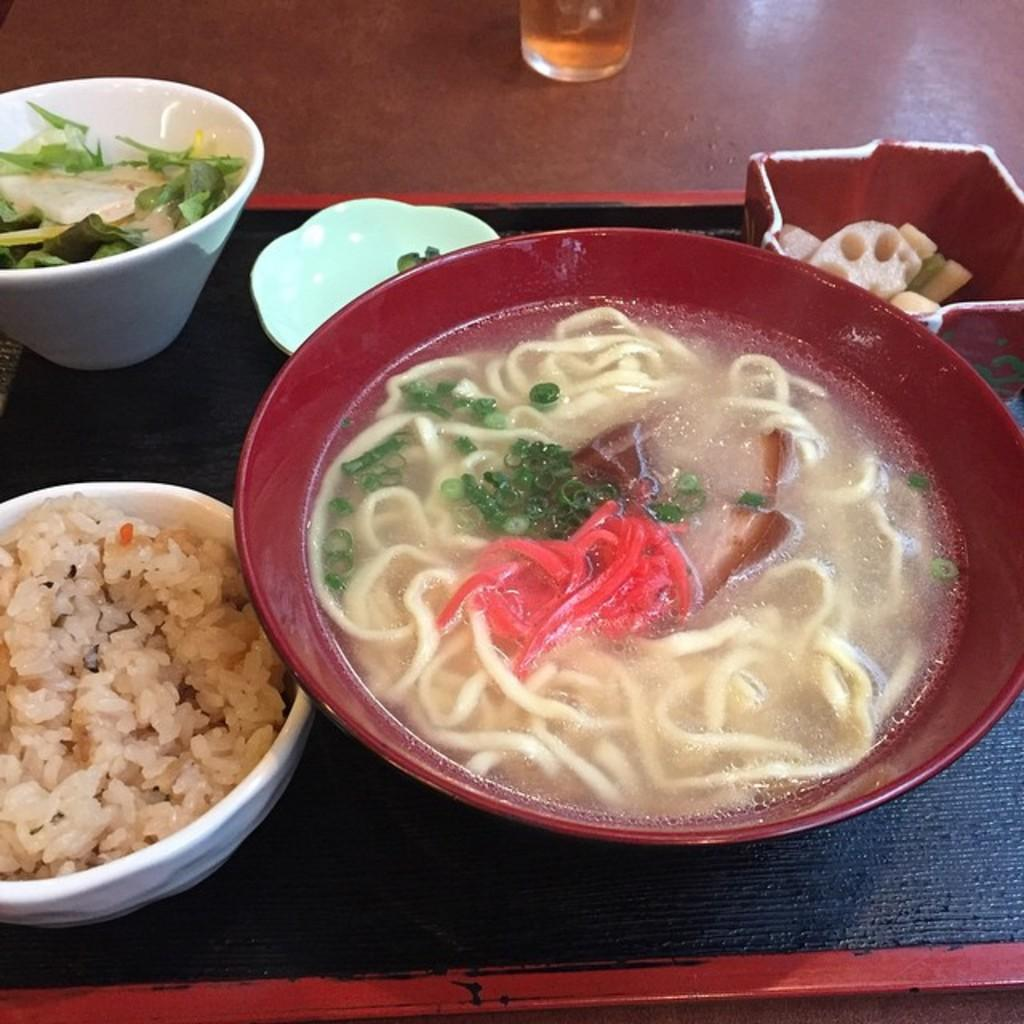What type of dishware is visible in the image? There are bowls, a plate, and a glass visible in the image. What is the purpose of the platform in the image? The platform is likely used to hold the tray, which contains the bowls and plate. What is the tray used for in the image? The tray is used to hold the bowls and plate, which contain food. What type of food is present in the image? Food is present in the image, but the specific type is not mentioned in the facts. How many snails can be seen crawling on the observation deck in the image? There are no snails or observation decks present in the image; it features dishware and food. 